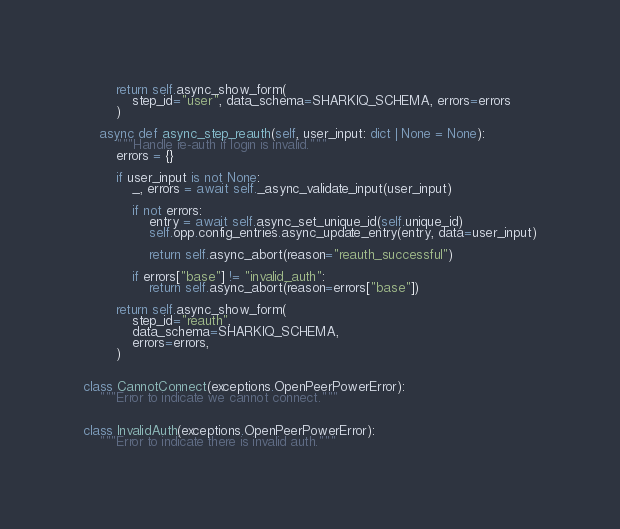<code> <loc_0><loc_0><loc_500><loc_500><_Python_>        return self.async_show_form(
            step_id="user", data_schema=SHARKIQ_SCHEMA, errors=errors
        )

    async def async_step_reauth(self, user_input: dict | None = None):
        """Handle re-auth if login is invalid."""
        errors = {}

        if user_input is not None:
            _, errors = await self._async_validate_input(user_input)

            if not errors:
                entry = await self.async_set_unique_id(self.unique_id)
                self.opp.config_entries.async_update_entry(entry, data=user_input)

                return self.async_abort(reason="reauth_successful")

            if errors["base"] != "invalid_auth":
                return self.async_abort(reason=errors["base"])

        return self.async_show_form(
            step_id="reauth",
            data_schema=SHARKIQ_SCHEMA,
            errors=errors,
        )


class CannotConnect(exceptions.OpenPeerPowerError):
    """Error to indicate we cannot connect."""


class InvalidAuth(exceptions.OpenPeerPowerError):
    """Error to indicate there is invalid auth."""
</code> 